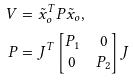Convert formula to latex. <formula><loc_0><loc_0><loc_500><loc_500>V & = \tilde { x } _ { o } ^ { T } P \tilde { x } _ { o } , \\ P & = J ^ { T } \begin{bmatrix} P _ { 1 } & 0 \\ 0 & P _ { 2 } \end{bmatrix} J</formula> 